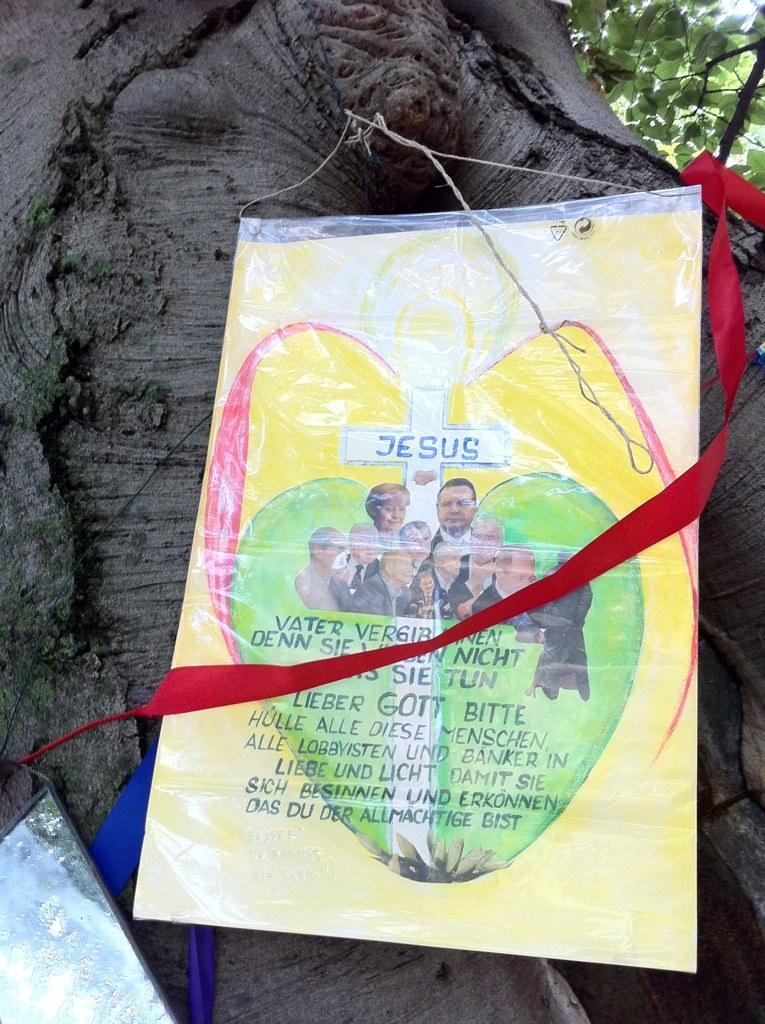What is attached to the tree in the image? There is a paper with writing on it in the image, and it is tied to a tree. What can be found near the tree and paper? There are other objects beside the paper and tree. Where is the lunchroom located in the image? There is no mention of a lunchroom in the image. How many houses can be seen in the image? There is no mention of houses in the image. Is there a hill visible in the image? There is no mention of a hill in the image. 